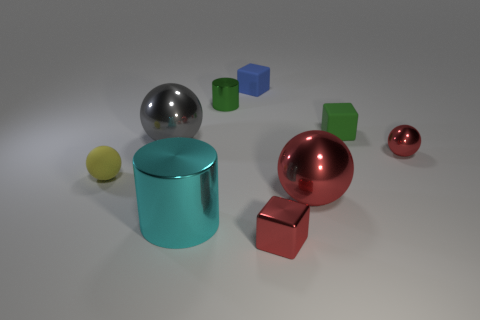There is a tiny block that is the same material as the tiny cylinder; what is its color?
Offer a very short reply. Red. There is a cube that is behind the shiny cylinder behind the large cyan shiny object; what color is it?
Offer a terse response. Blue. Is there a large metallic sphere of the same color as the metal block?
Offer a terse response. Yes. What shape is the green matte object that is the same size as the yellow ball?
Make the answer very short. Cube. There is a tiny cube in front of the tiny green block; what number of green matte things are on the left side of it?
Offer a terse response. 0. Do the tiny cylinder and the tiny metal ball have the same color?
Provide a short and direct response. No. How many other objects are the same material as the big gray thing?
Offer a terse response. 5. What shape is the tiny thing left of the big object that is behind the matte sphere?
Provide a succinct answer. Sphere. What is the size of the rubber block in front of the tiny blue rubber object?
Your answer should be compact. Small. Do the tiny cylinder and the large cylinder have the same material?
Ensure brevity in your answer.  Yes. 